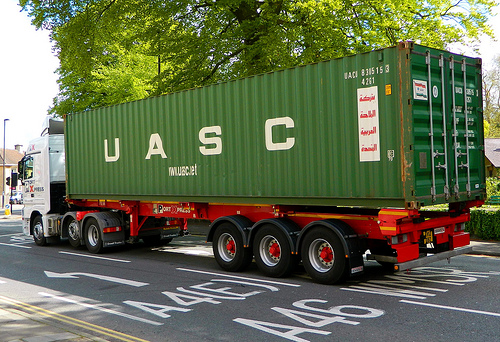Is the color of the sign different than the arrow? No, the color of the sign is the sharegpt4v/same as the color of the arrow. 